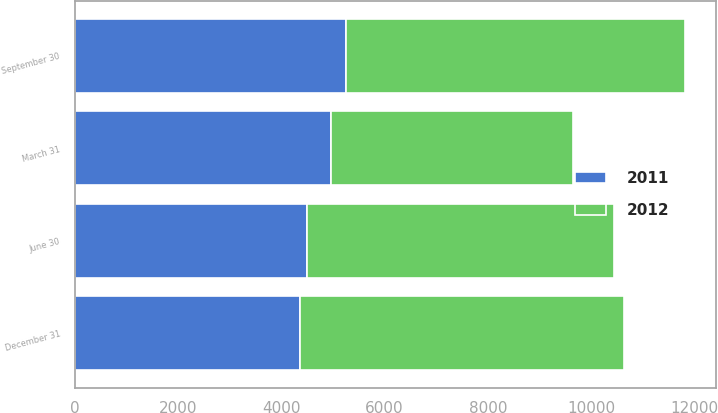Convert chart. <chart><loc_0><loc_0><loc_500><loc_500><stacked_bar_chart><ecel><fcel>March 31<fcel>June 30<fcel>September 30<fcel>December 31<nl><fcel>2012<fcel>4686<fcel>5954<fcel>6565<fcel>6284<nl><fcel>2011<fcel>4956<fcel>4496<fcel>5254<fcel>4357<nl></chart> 